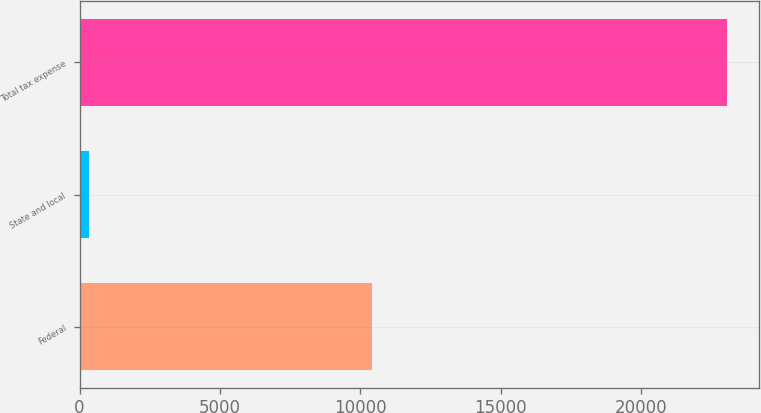Convert chart. <chart><loc_0><loc_0><loc_500><loc_500><bar_chart><fcel>Federal<fcel>State and local<fcel>Total tax expense<nl><fcel>10413<fcel>343<fcel>23031<nl></chart> 